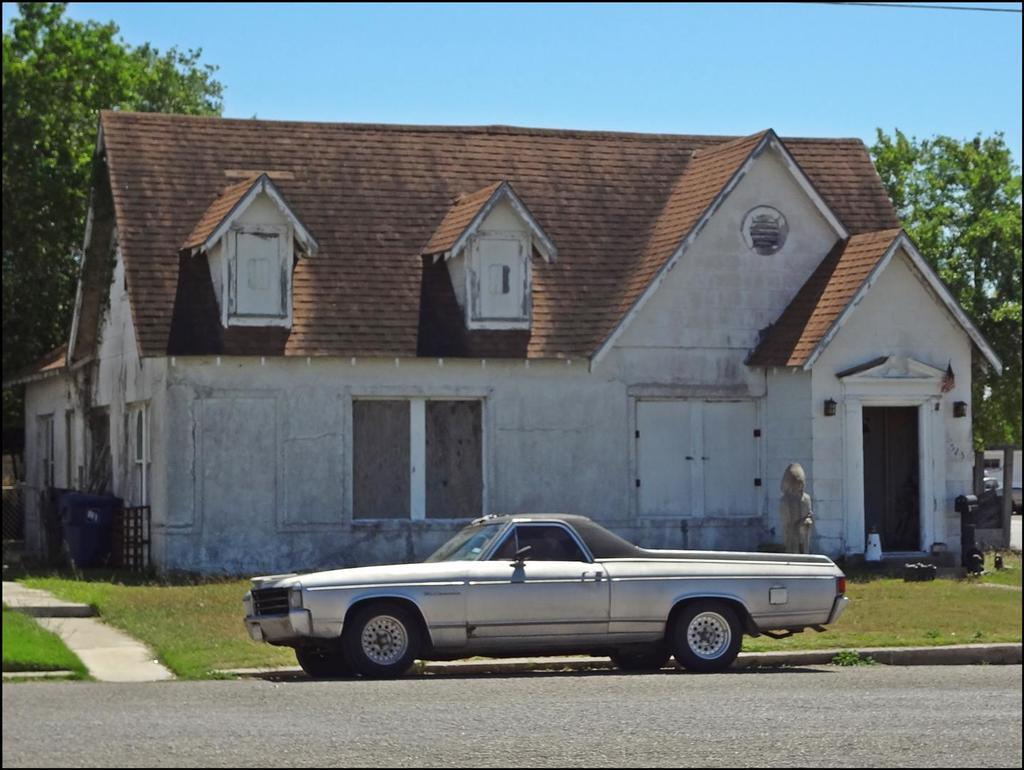What is the main subject in the foreground of the image? There is a vehicle on the road in the foreground of the image. What can be seen in the background of the image? There is a house, trees, grassland, and the sky visible in the background of the image. How many structures can be seen in the background of the image? There is one house visible in the background of the image. Where is the lake located in the image? There is no lake present in the image. What type of egg can be seen in the image? There are no eggs present in the image. 